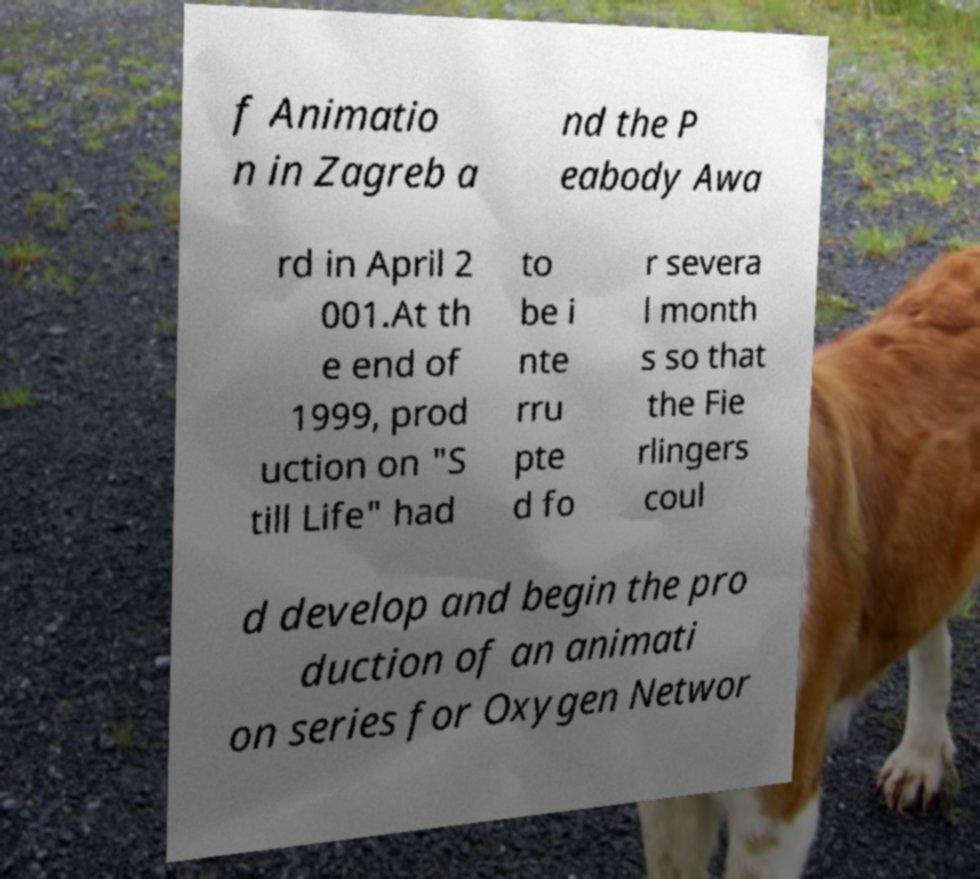Could you assist in decoding the text presented in this image and type it out clearly? f Animatio n in Zagreb a nd the P eabody Awa rd in April 2 001.At th e end of 1999, prod uction on "S till Life" had to be i nte rru pte d fo r severa l month s so that the Fie rlingers coul d develop and begin the pro duction of an animati on series for Oxygen Networ 